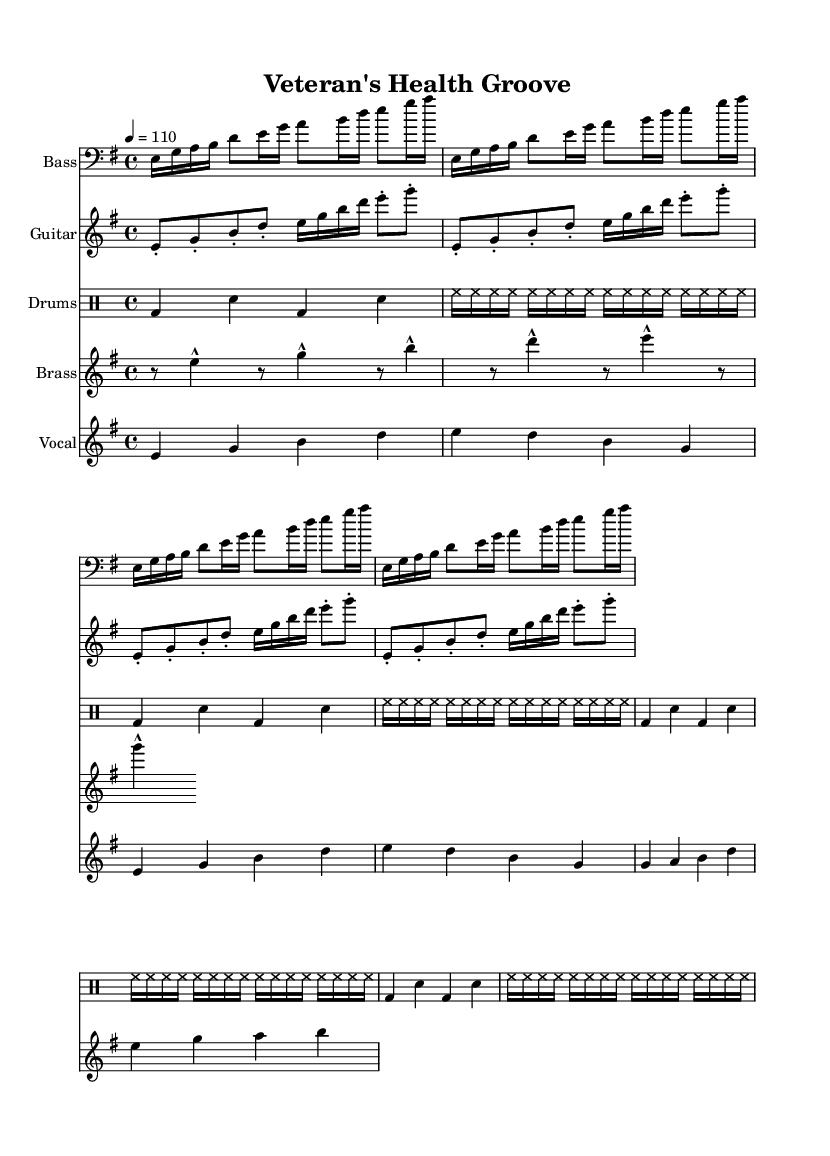What is the key signature of this music? The key signature is indicated at the beginning of the staff, which shows e minor with one sharp (F#).
Answer: e minor What is the time signature of this piece? The time signature is shown right after the key signature, which is 4/4, indicating four beats per measure.
Answer: 4/4 What is the tempo marking for the music? The tempo marking is placed above the staff and indicates a speed of 110 beats per minute.
Answer: 110 How many measures are in the vocal melody? The vocal melody section shows a total of 8 measures, which can be counted by identifying the beginning and end of phrases in the staff.
Answer: 8 What instruments are used in this composition? The instruments are listed at the beginning of each staff: Bass, Guitar, Drums, Brass, and Vocal.
Answer: Bass, Guitar, Drums, Brass, Vocal What rhythmic pattern is used in the drum section? The drum pattern consists of alternating bass drum and snare beats along with a high-hat pattern, which repeats four times for a consistent funk groove.
Answer: Alternating bass and snare with high-hat What style characteristics can you identify in the bass line? The bass line features a syncopated rhythm with a mix of short and long notes, typical for funk music, emphasizing groove and feel.
Answer: Syncopated rhythm 